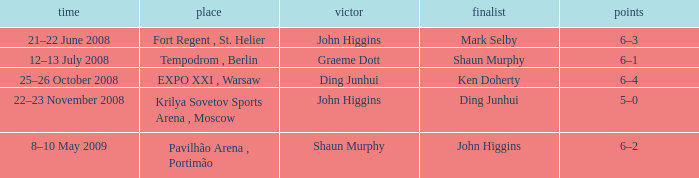Who was the winner in the match that had John Higgins as runner-up? Shaun Murphy. 